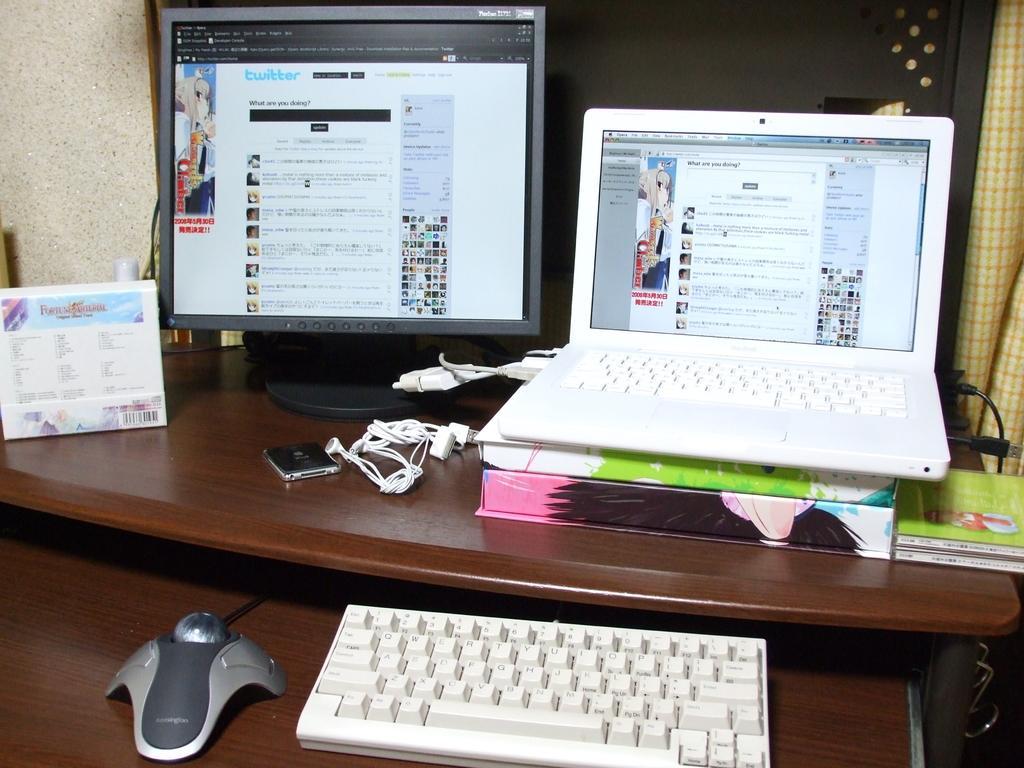Could you give a brief overview of what you see in this image? In the middle there is a table on that table there is a laptop and a monitor ,keyboard ,mouse ,headphones ,book and some other items. In the background there is a curtain and wall. 